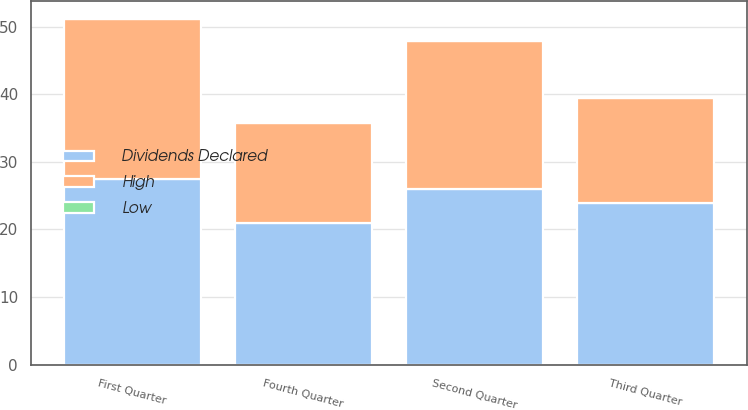Convert chart to OTSL. <chart><loc_0><loc_0><loc_500><loc_500><stacked_bar_chart><ecel><fcel>Fourth Quarter<fcel>Third Quarter<fcel>Second Quarter<fcel>First Quarter<nl><fcel>Dividends Declared<fcel>20.96<fcel>23.9<fcel>26<fcel>27.42<nl><fcel>High<fcel>14.85<fcel>15.51<fcel>21.92<fcel>23.77<nl><fcel>Low<fcel>0.12<fcel>0.12<fcel>0.12<fcel>0.11<nl></chart> 